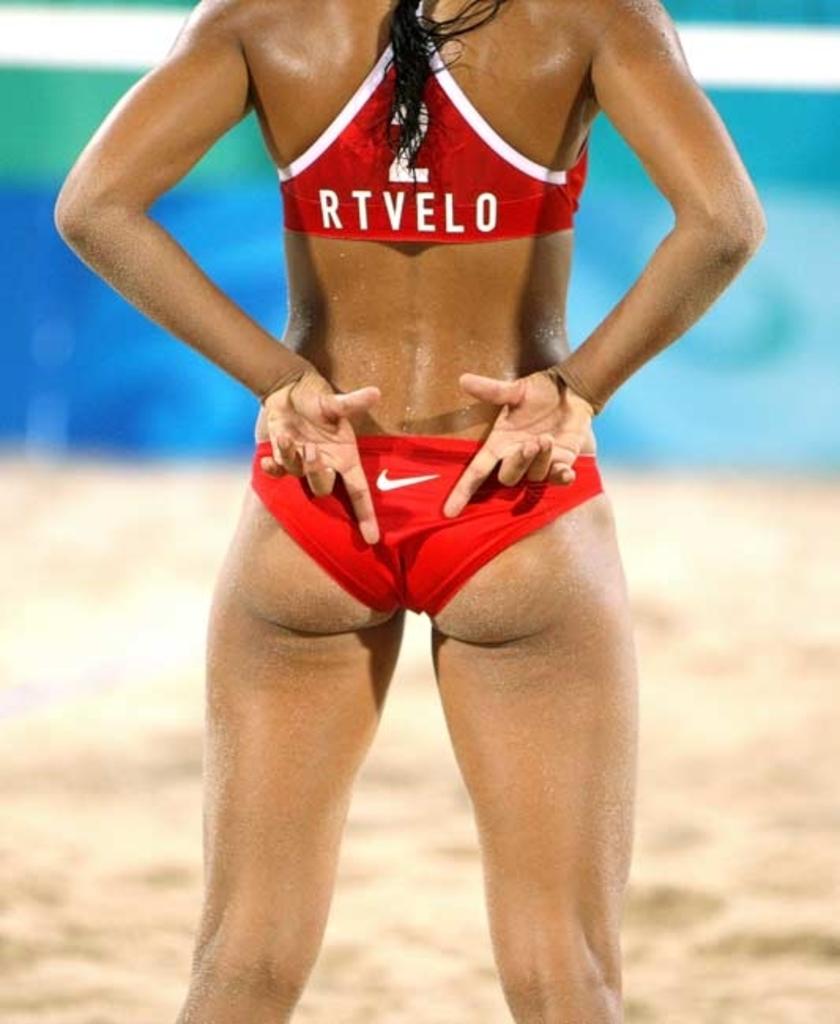What is on her top?
Your response must be concise. Rtvelo. What is the logo in  her bottoms?
Offer a terse response. Answering does not require reading text in the image. 